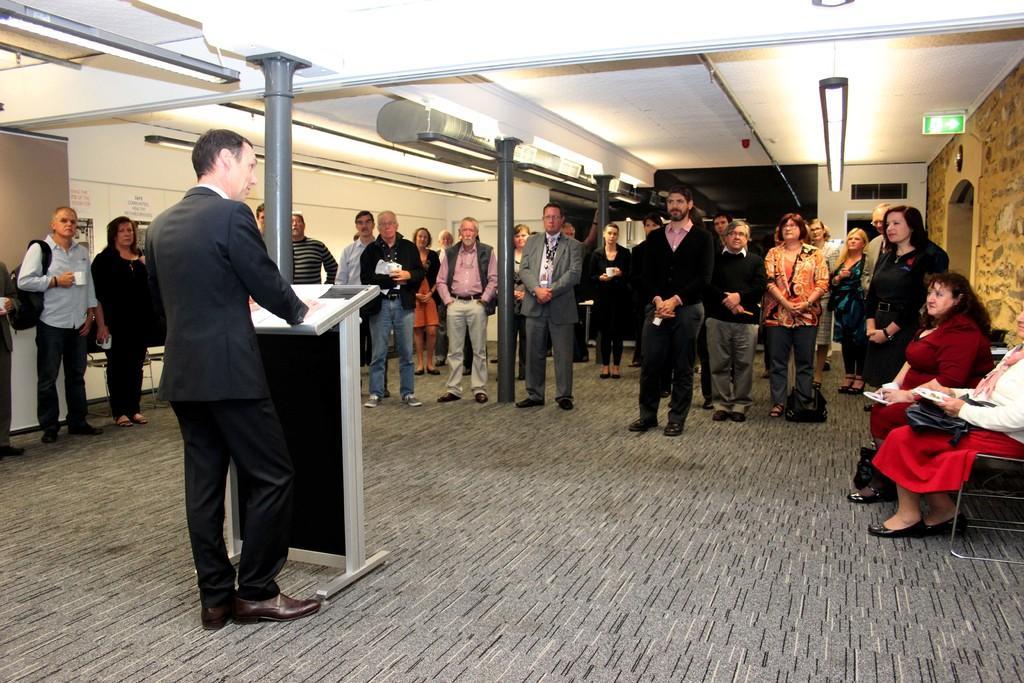In one or two sentences, can you explain what this image depicts? In this image, we can see people and some are holding objects. On the right, there are two people sitting on the stand and are holding objects and we can see a podium and we can see some papers on it. In the background, there are pillars, lights, boards and there is a wall. At the bottom, there is a floor. 